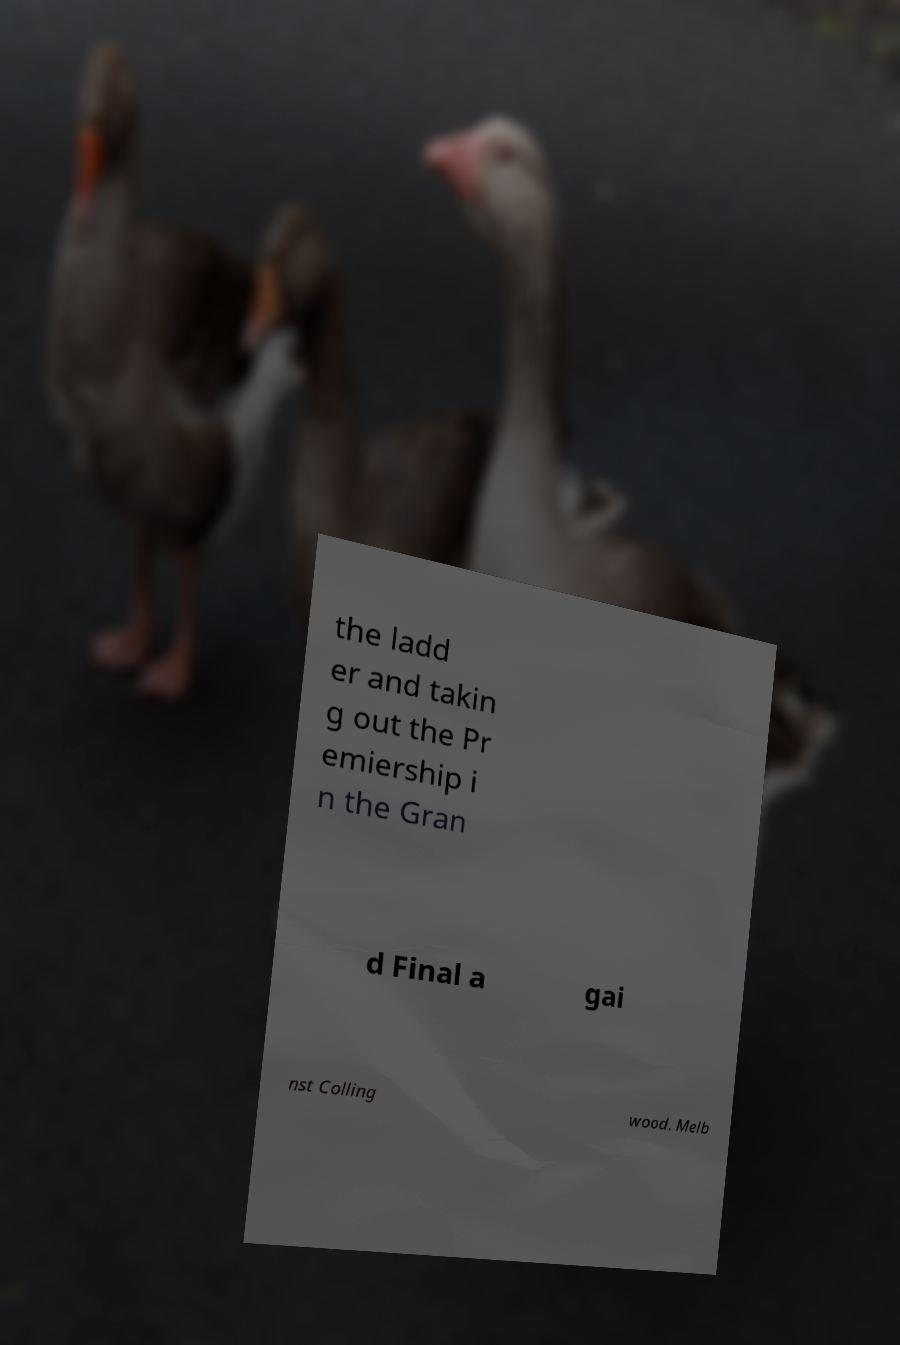What messages or text are displayed in this image? I need them in a readable, typed format. the ladd er and takin g out the Pr emiership i n the Gran d Final a gai nst Colling wood. Melb 